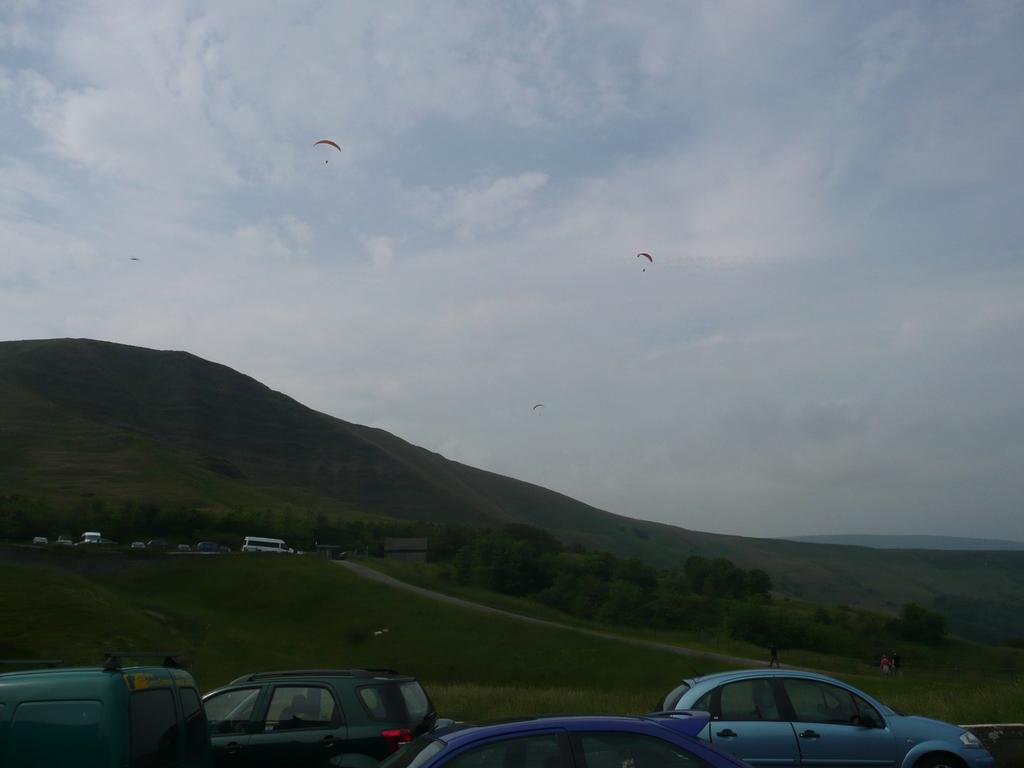What types of objects are present in the image? There are vehicles and trees in the image. Are there any objects related to aerial activities in the image? Yes, there are parachutes in the background of the image. What can be seen in the sky in the background of the image? There are clouds in the sky in the background of the image. What type of jewel can be seen on the boot in the image? There is no jewel or boot present in the image. 